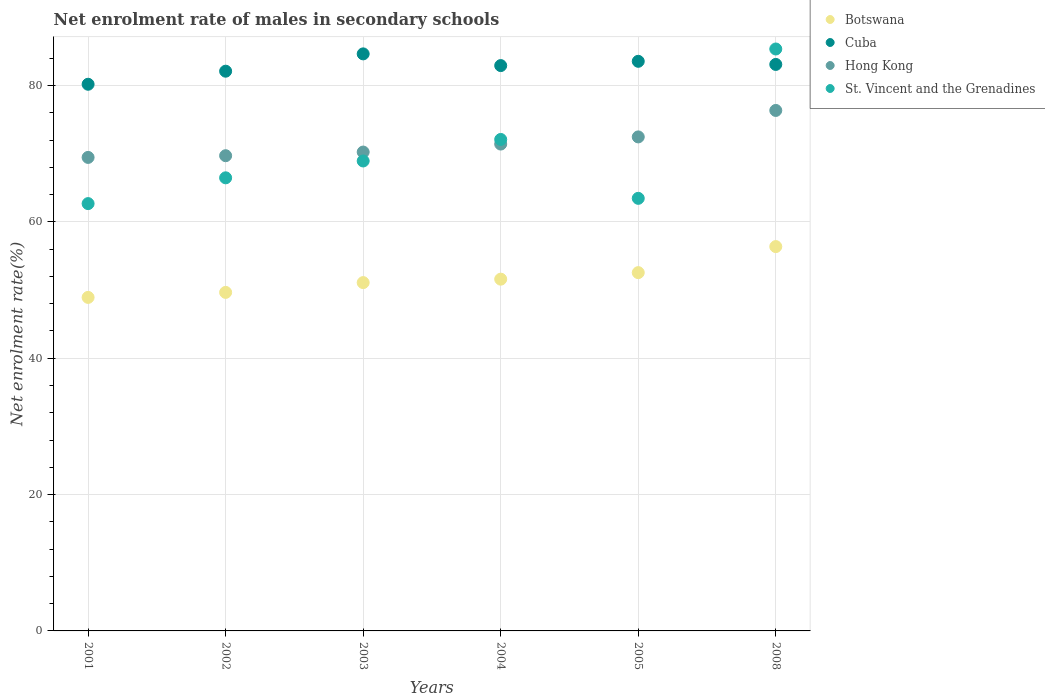How many different coloured dotlines are there?
Your answer should be compact. 4. Is the number of dotlines equal to the number of legend labels?
Make the answer very short. Yes. What is the net enrolment rate of males in secondary schools in Cuba in 2004?
Offer a very short reply. 82.92. Across all years, what is the maximum net enrolment rate of males in secondary schools in Cuba?
Your response must be concise. 84.63. Across all years, what is the minimum net enrolment rate of males in secondary schools in St. Vincent and the Grenadines?
Give a very brief answer. 62.67. In which year was the net enrolment rate of males in secondary schools in Hong Kong maximum?
Offer a terse response. 2008. What is the total net enrolment rate of males in secondary schools in Botswana in the graph?
Your answer should be very brief. 310.17. What is the difference between the net enrolment rate of males in secondary schools in Hong Kong in 2004 and that in 2008?
Make the answer very short. -4.93. What is the difference between the net enrolment rate of males in secondary schools in St. Vincent and the Grenadines in 2002 and the net enrolment rate of males in secondary schools in Hong Kong in 2005?
Provide a short and direct response. -6. What is the average net enrolment rate of males in secondary schools in Botswana per year?
Give a very brief answer. 51.69. In the year 2005, what is the difference between the net enrolment rate of males in secondary schools in Cuba and net enrolment rate of males in secondary schools in Botswana?
Provide a succinct answer. 30.99. What is the ratio of the net enrolment rate of males in secondary schools in Hong Kong in 2002 to that in 2005?
Offer a very short reply. 0.96. What is the difference between the highest and the second highest net enrolment rate of males in secondary schools in St. Vincent and the Grenadines?
Make the answer very short. 13.27. What is the difference between the highest and the lowest net enrolment rate of males in secondary schools in Hong Kong?
Provide a short and direct response. 6.89. In how many years, is the net enrolment rate of males in secondary schools in Cuba greater than the average net enrolment rate of males in secondary schools in Cuba taken over all years?
Your answer should be very brief. 4. Is the sum of the net enrolment rate of males in secondary schools in Botswana in 2003 and 2005 greater than the maximum net enrolment rate of males in secondary schools in Hong Kong across all years?
Make the answer very short. Yes. Is it the case that in every year, the sum of the net enrolment rate of males in secondary schools in Hong Kong and net enrolment rate of males in secondary schools in St. Vincent and the Grenadines  is greater than the sum of net enrolment rate of males in secondary schools in Cuba and net enrolment rate of males in secondary schools in Botswana?
Your answer should be very brief. Yes. Is it the case that in every year, the sum of the net enrolment rate of males in secondary schools in Cuba and net enrolment rate of males in secondary schools in Botswana  is greater than the net enrolment rate of males in secondary schools in Hong Kong?
Give a very brief answer. Yes. Is the net enrolment rate of males in secondary schools in Hong Kong strictly greater than the net enrolment rate of males in secondary schools in Cuba over the years?
Keep it short and to the point. No. How many dotlines are there?
Ensure brevity in your answer.  4. Are the values on the major ticks of Y-axis written in scientific E-notation?
Offer a terse response. No. Does the graph contain any zero values?
Provide a short and direct response. No. Does the graph contain grids?
Your answer should be compact. Yes. Where does the legend appear in the graph?
Provide a succinct answer. Top right. How many legend labels are there?
Your answer should be very brief. 4. How are the legend labels stacked?
Your answer should be compact. Vertical. What is the title of the graph?
Your response must be concise. Net enrolment rate of males in secondary schools. Does "Singapore" appear as one of the legend labels in the graph?
Provide a succinct answer. No. What is the label or title of the Y-axis?
Provide a short and direct response. Net enrolment rate(%). What is the Net enrolment rate(%) of Botswana in 2001?
Keep it short and to the point. 48.92. What is the Net enrolment rate(%) in Cuba in 2001?
Offer a very short reply. 80.18. What is the Net enrolment rate(%) of Hong Kong in 2001?
Your answer should be very brief. 69.45. What is the Net enrolment rate(%) of St. Vincent and the Grenadines in 2001?
Provide a short and direct response. 62.67. What is the Net enrolment rate(%) of Botswana in 2002?
Make the answer very short. 49.65. What is the Net enrolment rate(%) in Cuba in 2002?
Ensure brevity in your answer.  82.09. What is the Net enrolment rate(%) of Hong Kong in 2002?
Offer a terse response. 69.7. What is the Net enrolment rate(%) in St. Vincent and the Grenadines in 2002?
Offer a very short reply. 66.46. What is the Net enrolment rate(%) of Botswana in 2003?
Provide a short and direct response. 51.09. What is the Net enrolment rate(%) in Cuba in 2003?
Ensure brevity in your answer.  84.63. What is the Net enrolment rate(%) of Hong Kong in 2003?
Provide a short and direct response. 70.24. What is the Net enrolment rate(%) in St. Vincent and the Grenadines in 2003?
Ensure brevity in your answer.  68.93. What is the Net enrolment rate(%) of Botswana in 2004?
Ensure brevity in your answer.  51.59. What is the Net enrolment rate(%) in Cuba in 2004?
Your answer should be compact. 82.92. What is the Net enrolment rate(%) of Hong Kong in 2004?
Your answer should be very brief. 71.41. What is the Net enrolment rate(%) of St. Vincent and the Grenadines in 2004?
Your answer should be compact. 72.08. What is the Net enrolment rate(%) in Botswana in 2005?
Make the answer very short. 52.55. What is the Net enrolment rate(%) in Cuba in 2005?
Offer a terse response. 83.54. What is the Net enrolment rate(%) in Hong Kong in 2005?
Your answer should be very brief. 72.46. What is the Net enrolment rate(%) in St. Vincent and the Grenadines in 2005?
Give a very brief answer. 63.45. What is the Net enrolment rate(%) of Botswana in 2008?
Ensure brevity in your answer.  56.37. What is the Net enrolment rate(%) of Cuba in 2008?
Make the answer very short. 83.09. What is the Net enrolment rate(%) in Hong Kong in 2008?
Provide a short and direct response. 76.34. What is the Net enrolment rate(%) of St. Vincent and the Grenadines in 2008?
Ensure brevity in your answer.  85.35. Across all years, what is the maximum Net enrolment rate(%) in Botswana?
Your response must be concise. 56.37. Across all years, what is the maximum Net enrolment rate(%) in Cuba?
Offer a very short reply. 84.63. Across all years, what is the maximum Net enrolment rate(%) of Hong Kong?
Your answer should be very brief. 76.34. Across all years, what is the maximum Net enrolment rate(%) of St. Vincent and the Grenadines?
Make the answer very short. 85.35. Across all years, what is the minimum Net enrolment rate(%) of Botswana?
Provide a short and direct response. 48.92. Across all years, what is the minimum Net enrolment rate(%) in Cuba?
Offer a terse response. 80.18. Across all years, what is the minimum Net enrolment rate(%) of Hong Kong?
Ensure brevity in your answer.  69.45. Across all years, what is the minimum Net enrolment rate(%) of St. Vincent and the Grenadines?
Give a very brief answer. 62.67. What is the total Net enrolment rate(%) in Botswana in the graph?
Provide a short and direct response. 310.17. What is the total Net enrolment rate(%) of Cuba in the graph?
Give a very brief answer. 496.46. What is the total Net enrolment rate(%) in Hong Kong in the graph?
Your answer should be compact. 429.59. What is the total Net enrolment rate(%) of St. Vincent and the Grenadines in the graph?
Make the answer very short. 418.94. What is the difference between the Net enrolment rate(%) in Botswana in 2001 and that in 2002?
Make the answer very short. -0.73. What is the difference between the Net enrolment rate(%) in Cuba in 2001 and that in 2002?
Provide a short and direct response. -1.92. What is the difference between the Net enrolment rate(%) of Hong Kong in 2001 and that in 2002?
Provide a short and direct response. -0.25. What is the difference between the Net enrolment rate(%) in St. Vincent and the Grenadines in 2001 and that in 2002?
Your response must be concise. -3.78. What is the difference between the Net enrolment rate(%) in Botswana in 2001 and that in 2003?
Your response must be concise. -2.17. What is the difference between the Net enrolment rate(%) of Cuba in 2001 and that in 2003?
Your answer should be compact. -4.46. What is the difference between the Net enrolment rate(%) of Hong Kong in 2001 and that in 2003?
Your answer should be compact. -0.79. What is the difference between the Net enrolment rate(%) of St. Vincent and the Grenadines in 2001 and that in 2003?
Provide a succinct answer. -6.25. What is the difference between the Net enrolment rate(%) of Botswana in 2001 and that in 2004?
Give a very brief answer. -2.68. What is the difference between the Net enrolment rate(%) in Cuba in 2001 and that in 2004?
Your answer should be very brief. -2.74. What is the difference between the Net enrolment rate(%) of Hong Kong in 2001 and that in 2004?
Keep it short and to the point. -1.96. What is the difference between the Net enrolment rate(%) in St. Vincent and the Grenadines in 2001 and that in 2004?
Make the answer very short. -9.41. What is the difference between the Net enrolment rate(%) in Botswana in 2001 and that in 2005?
Your answer should be compact. -3.63. What is the difference between the Net enrolment rate(%) of Cuba in 2001 and that in 2005?
Provide a short and direct response. -3.37. What is the difference between the Net enrolment rate(%) of Hong Kong in 2001 and that in 2005?
Ensure brevity in your answer.  -3.01. What is the difference between the Net enrolment rate(%) in St. Vincent and the Grenadines in 2001 and that in 2005?
Provide a short and direct response. -0.77. What is the difference between the Net enrolment rate(%) in Botswana in 2001 and that in 2008?
Provide a succinct answer. -7.45. What is the difference between the Net enrolment rate(%) in Cuba in 2001 and that in 2008?
Ensure brevity in your answer.  -2.91. What is the difference between the Net enrolment rate(%) in Hong Kong in 2001 and that in 2008?
Provide a short and direct response. -6.89. What is the difference between the Net enrolment rate(%) in St. Vincent and the Grenadines in 2001 and that in 2008?
Your answer should be very brief. -22.68. What is the difference between the Net enrolment rate(%) in Botswana in 2002 and that in 2003?
Your answer should be compact. -1.44. What is the difference between the Net enrolment rate(%) of Cuba in 2002 and that in 2003?
Your answer should be very brief. -2.54. What is the difference between the Net enrolment rate(%) in Hong Kong in 2002 and that in 2003?
Keep it short and to the point. -0.54. What is the difference between the Net enrolment rate(%) in St. Vincent and the Grenadines in 2002 and that in 2003?
Make the answer very short. -2.47. What is the difference between the Net enrolment rate(%) of Botswana in 2002 and that in 2004?
Your answer should be very brief. -1.94. What is the difference between the Net enrolment rate(%) of Cuba in 2002 and that in 2004?
Make the answer very short. -0.82. What is the difference between the Net enrolment rate(%) of Hong Kong in 2002 and that in 2004?
Provide a short and direct response. -1.71. What is the difference between the Net enrolment rate(%) in St. Vincent and the Grenadines in 2002 and that in 2004?
Offer a very short reply. -5.63. What is the difference between the Net enrolment rate(%) in Botswana in 2002 and that in 2005?
Your answer should be very brief. -2.9. What is the difference between the Net enrolment rate(%) of Cuba in 2002 and that in 2005?
Offer a terse response. -1.45. What is the difference between the Net enrolment rate(%) of Hong Kong in 2002 and that in 2005?
Your response must be concise. -2.76. What is the difference between the Net enrolment rate(%) of St. Vincent and the Grenadines in 2002 and that in 2005?
Offer a terse response. 3.01. What is the difference between the Net enrolment rate(%) in Botswana in 2002 and that in 2008?
Offer a terse response. -6.72. What is the difference between the Net enrolment rate(%) in Cuba in 2002 and that in 2008?
Offer a very short reply. -0.99. What is the difference between the Net enrolment rate(%) of Hong Kong in 2002 and that in 2008?
Give a very brief answer. -6.64. What is the difference between the Net enrolment rate(%) in St. Vincent and the Grenadines in 2002 and that in 2008?
Give a very brief answer. -18.89. What is the difference between the Net enrolment rate(%) of Botswana in 2003 and that in 2004?
Offer a very short reply. -0.51. What is the difference between the Net enrolment rate(%) in Cuba in 2003 and that in 2004?
Offer a terse response. 1.72. What is the difference between the Net enrolment rate(%) in Hong Kong in 2003 and that in 2004?
Your answer should be very brief. -1.17. What is the difference between the Net enrolment rate(%) of St. Vincent and the Grenadines in 2003 and that in 2004?
Keep it short and to the point. -3.16. What is the difference between the Net enrolment rate(%) of Botswana in 2003 and that in 2005?
Offer a very short reply. -1.46. What is the difference between the Net enrolment rate(%) of Cuba in 2003 and that in 2005?
Ensure brevity in your answer.  1.09. What is the difference between the Net enrolment rate(%) in Hong Kong in 2003 and that in 2005?
Keep it short and to the point. -2.22. What is the difference between the Net enrolment rate(%) in St. Vincent and the Grenadines in 2003 and that in 2005?
Make the answer very short. 5.48. What is the difference between the Net enrolment rate(%) in Botswana in 2003 and that in 2008?
Your answer should be very brief. -5.28. What is the difference between the Net enrolment rate(%) of Cuba in 2003 and that in 2008?
Make the answer very short. 1.55. What is the difference between the Net enrolment rate(%) of Hong Kong in 2003 and that in 2008?
Offer a terse response. -6.1. What is the difference between the Net enrolment rate(%) in St. Vincent and the Grenadines in 2003 and that in 2008?
Keep it short and to the point. -16.42. What is the difference between the Net enrolment rate(%) in Botswana in 2004 and that in 2005?
Provide a succinct answer. -0.96. What is the difference between the Net enrolment rate(%) in Cuba in 2004 and that in 2005?
Your answer should be very brief. -0.63. What is the difference between the Net enrolment rate(%) in Hong Kong in 2004 and that in 2005?
Your answer should be compact. -1.05. What is the difference between the Net enrolment rate(%) of St. Vincent and the Grenadines in 2004 and that in 2005?
Offer a very short reply. 8.64. What is the difference between the Net enrolment rate(%) of Botswana in 2004 and that in 2008?
Your answer should be compact. -4.78. What is the difference between the Net enrolment rate(%) in Cuba in 2004 and that in 2008?
Provide a short and direct response. -0.17. What is the difference between the Net enrolment rate(%) of Hong Kong in 2004 and that in 2008?
Offer a very short reply. -4.93. What is the difference between the Net enrolment rate(%) of St. Vincent and the Grenadines in 2004 and that in 2008?
Provide a short and direct response. -13.27. What is the difference between the Net enrolment rate(%) in Botswana in 2005 and that in 2008?
Offer a very short reply. -3.82. What is the difference between the Net enrolment rate(%) of Cuba in 2005 and that in 2008?
Offer a terse response. 0.46. What is the difference between the Net enrolment rate(%) of Hong Kong in 2005 and that in 2008?
Your response must be concise. -3.88. What is the difference between the Net enrolment rate(%) of St. Vincent and the Grenadines in 2005 and that in 2008?
Offer a terse response. -21.9. What is the difference between the Net enrolment rate(%) of Botswana in 2001 and the Net enrolment rate(%) of Cuba in 2002?
Offer a very short reply. -33.18. What is the difference between the Net enrolment rate(%) of Botswana in 2001 and the Net enrolment rate(%) of Hong Kong in 2002?
Keep it short and to the point. -20.78. What is the difference between the Net enrolment rate(%) of Botswana in 2001 and the Net enrolment rate(%) of St. Vincent and the Grenadines in 2002?
Offer a terse response. -17.54. What is the difference between the Net enrolment rate(%) of Cuba in 2001 and the Net enrolment rate(%) of Hong Kong in 2002?
Your response must be concise. 10.48. What is the difference between the Net enrolment rate(%) of Cuba in 2001 and the Net enrolment rate(%) of St. Vincent and the Grenadines in 2002?
Keep it short and to the point. 13.72. What is the difference between the Net enrolment rate(%) in Hong Kong in 2001 and the Net enrolment rate(%) in St. Vincent and the Grenadines in 2002?
Offer a very short reply. 2.99. What is the difference between the Net enrolment rate(%) in Botswana in 2001 and the Net enrolment rate(%) in Cuba in 2003?
Give a very brief answer. -35.72. What is the difference between the Net enrolment rate(%) of Botswana in 2001 and the Net enrolment rate(%) of Hong Kong in 2003?
Keep it short and to the point. -21.32. What is the difference between the Net enrolment rate(%) of Botswana in 2001 and the Net enrolment rate(%) of St. Vincent and the Grenadines in 2003?
Provide a short and direct response. -20.01. What is the difference between the Net enrolment rate(%) of Cuba in 2001 and the Net enrolment rate(%) of Hong Kong in 2003?
Offer a very short reply. 9.94. What is the difference between the Net enrolment rate(%) in Cuba in 2001 and the Net enrolment rate(%) in St. Vincent and the Grenadines in 2003?
Your response must be concise. 11.25. What is the difference between the Net enrolment rate(%) in Hong Kong in 2001 and the Net enrolment rate(%) in St. Vincent and the Grenadines in 2003?
Provide a succinct answer. 0.52. What is the difference between the Net enrolment rate(%) in Botswana in 2001 and the Net enrolment rate(%) in Cuba in 2004?
Keep it short and to the point. -34. What is the difference between the Net enrolment rate(%) of Botswana in 2001 and the Net enrolment rate(%) of Hong Kong in 2004?
Offer a terse response. -22.49. What is the difference between the Net enrolment rate(%) of Botswana in 2001 and the Net enrolment rate(%) of St. Vincent and the Grenadines in 2004?
Your answer should be very brief. -23.17. What is the difference between the Net enrolment rate(%) in Cuba in 2001 and the Net enrolment rate(%) in Hong Kong in 2004?
Your answer should be very brief. 8.77. What is the difference between the Net enrolment rate(%) in Cuba in 2001 and the Net enrolment rate(%) in St. Vincent and the Grenadines in 2004?
Your answer should be compact. 8.09. What is the difference between the Net enrolment rate(%) in Hong Kong in 2001 and the Net enrolment rate(%) in St. Vincent and the Grenadines in 2004?
Ensure brevity in your answer.  -2.63. What is the difference between the Net enrolment rate(%) in Botswana in 2001 and the Net enrolment rate(%) in Cuba in 2005?
Ensure brevity in your answer.  -34.63. What is the difference between the Net enrolment rate(%) in Botswana in 2001 and the Net enrolment rate(%) in Hong Kong in 2005?
Ensure brevity in your answer.  -23.54. What is the difference between the Net enrolment rate(%) of Botswana in 2001 and the Net enrolment rate(%) of St. Vincent and the Grenadines in 2005?
Keep it short and to the point. -14.53. What is the difference between the Net enrolment rate(%) in Cuba in 2001 and the Net enrolment rate(%) in Hong Kong in 2005?
Offer a very short reply. 7.72. What is the difference between the Net enrolment rate(%) of Cuba in 2001 and the Net enrolment rate(%) of St. Vincent and the Grenadines in 2005?
Ensure brevity in your answer.  16.73. What is the difference between the Net enrolment rate(%) in Hong Kong in 2001 and the Net enrolment rate(%) in St. Vincent and the Grenadines in 2005?
Keep it short and to the point. 6. What is the difference between the Net enrolment rate(%) in Botswana in 2001 and the Net enrolment rate(%) in Cuba in 2008?
Your answer should be very brief. -34.17. What is the difference between the Net enrolment rate(%) of Botswana in 2001 and the Net enrolment rate(%) of Hong Kong in 2008?
Keep it short and to the point. -27.42. What is the difference between the Net enrolment rate(%) of Botswana in 2001 and the Net enrolment rate(%) of St. Vincent and the Grenadines in 2008?
Give a very brief answer. -36.43. What is the difference between the Net enrolment rate(%) in Cuba in 2001 and the Net enrolment rate(%) in Hong Kong in 2008?
Keep it short and to the point. 3.84. What is the difference between the Net enrolment rate(%) of Cuba in 2001 and the Net enrolment rate(%) of St. Vincent and the Grenadines in 2008?
Provide a succinct answer. -5.17. What is the difference between the Net enrolment rate(%) of Hong Kong in 2001 and the Net enrolment rate(%) of St. Vincent and the Grenadines in 2008?
Offer a very short reply. -15.9. What is the difference between the Net enrolment rate(%) in Botswana in 2002 and the Net enrolment rate(%) in Cuba in 2003?
Offer a very short reply. -34.98. What is the difference between the Net enrolment rate(%) of Botswana in 2002 and the Net enrolment rate(%) of Hong Kong in 2003?
Provide a succinct answer. -20.58. What is the difference between the Net enrolment rate(%) of Botswana in 2002 and the Net enrolment rate(%) of St. Vincent and the Grenadines in 2003?
Give a very brief answer. -19.28. What is the difference between the Net enrolment rate(%) of Cuba in 2002 and the Net enrolment rate(%) of Hong Kong in 2003?
Ensure brevity in your answer.  11.86. What is the difference between the Net enrolment rate(%) in Cuba in 2002 and the Net enrolment rate(%) in St. Vincent and the Grenadines in 2003?
Provide a short and direct response. 13.17. What is the difference between the Net enrolment rate(%) of Hong Kong in 2002 and the Net enrolment rate(%) of St. Vincent and the Grenadines in 2003?
Your answer should be compact. 0.77. What is the difference between the Net enrolment rate(%) in Botswana in 2002 and the Net enrolment rate(%) in Cuba in 2004?
Offer a terse response. -33.27. What is the difference between the Net enrolment rate(%) in Botswana in 2002 and the Net enrolment rate(%) in Hong Kong in 2004?
Your answer should be compact. -21.76. What is the difference between the Net enrolment rate(%) of Botswana in 2002 and the Net enrolment rate(%) of St. Vincent and the Grenadines in 2004?
Your response must be concise. -22.43. What is the difference between the Net enrolment rate(%) in Cuba in 2002 and the Net enrolment rate(%) in Hong Kong in 2004?
Provide a short and direct response. 10.69. What is the difference between the Net enrolment rate(%) of Cuba in 2002 and the Net enrolment rate(%) of St. Vincent and the Grenadines in 2004?
Offer a very short reply. 10.01. What is the difference between the Net enrolment rate(%) in Hong Kong in 2002 and the Net enrolment rate(%) in St. Vincent and the Grenadines in 2004?
Your answer should be compact. -2.38. What is the difference between the Net enrolment rate(%) in Botswana in 2002 and the Net enrolment rate(%) in Cuba in 2005?
Give a very brief answer. -33.89. What is the difference between the Net enrolment rate(%) in Botswana in 2002 and the Net enrolment rate(%) in Hong Kong in 2005?
Your answer should be very brief. -22.81. What is the difference between the Net enrolment rate(%) of Botswana in 2002 and the Net enrolment rate(%) of St. Vincent and the Grenadines in 2005?
Your answer should be very brief. -13.8. What is the difference between the Net enrolment rate(%) in Cuba in 2002 and the Net enrolment rate(%) in Hong Kong in 2005?
Your answer should be compact. 9.64. What is the difference between the Net enrolment rate(%) in Cuba in 2002 and the Net enrolment rate(%) in St. Vincent and the Grenadines in 2005?
Provide a succinct answer. 18.65. What is the difference between the Net enrolment rate(%) of Hong Kong in 2002 and the Net enrolment rate(%) of St. Vincent and the Grenadines in 2005?
Your answer should be compact. 6.25. What is the difference between the Net enrolment rate(%) of Botswana in 2002 and the Net enrolment rate(%) of Cuba in 2008?
Keep it short and to the point. -33.44. What is the difference between the Net enrolment rate(%) of Botswana in 2002 and the Net enrolment rate(%) of Hong Kong in 2008?
Your answer should be compact. -26.69. What is the difference between the Net enrolment rate(%) in Botswana in 2002 and the Net enrolment rate(%) in St. Vincent and the Grenadines in 2008?
Give a very brief answer. -35.7. What is the difference between the Net enrolment rate(%) of Cuba in 2002 and the Net enrolment rate(%) of Hong Kong in 2008?
Make the answer very short. 5.76. What is the difference between the Net enrolment rate(%) in Cuba in 2002 and the Net enrolment rate(%) in St. Vincent and the Grenadines in 2008?
Keep it short and to the point. -3.26. What is the difference between the Net enrolment rate(%) of Hong Kong in 2002 and the Net enrolment rate(%) of St. Vincent and the Grenadines in 2008?
Make the answer very short. -15.65. What is the difference between the Net enrolment rate(%) in Botswana in 2003 and the Net enrolment rate(%) in Cuba in 2004?
Ensure brevity in your answer.  -31.83. What is the difference between the Net enrolment rate(%) of Botswana in 2003 and the Net enrolment rate(%) of Hong Kong in 2004?
Make the answer very short. -20.32. What is the difference between the Net enrolment rate(%) of Botswana in 2003 and the Net enrolment rate(%) of St. Vincent and the Grenadines in 2004?
Offer a terse response. -21. What is the difference between the Net enrolment rate(%) in Cuba in 2003 and the Net enrolment rate(%) in Hong Kong in 2004?
Provide a short and direct response. 13.23. What is the difference between the Net enrolment rate(%) of Cuba in 2003 and the Net enrolment rate(%) of St. Vincent and the Grenadines in 2004?
Give a very brief answer. 12.55. What is the difference between the Net enrolment rate(%) in Hong Kong in 2003 and the Net enrolment rate(%) in St. Vincent and the Grenadines in 2004?
Provide a succinct answer. -1.85. What is the difference between the Net enrolment rate(%) of Botswana in 2003 and the Net enrolment rate(%) of Cuba in 2005?
Provide a succinct answer. -32.46. What is the difference between the Net enrolment rate(%) in Botswana in 2003 and the Net enrolment rate(%) in Hong Kong in 2005?
Your answer should be compact. -21.37. What is the difference between the Net enrolment rate(%) of Botswana in 2003 and the Net enrolment rate(%) of St. Vincent and the Grenadines in 2005?
Provide a succinct answer. -12.36. What is the difference between the Net enrolment rate(%) of Cuba in 2003 and the Net enrolment rate(%) of Hong Kong in 2005?
Provide a short and direct response. 12.18. What is the difference between the Net enrolment rate(%) in Cuba in 2003 and the Net enrolment rate(%) in St. Vincent and the Grenadines in 2005?
Your response must be concise. 21.19. What is the difference between the Net enrolment rate(%) in Hong Kong in 2003 and the Net enrolment rate(%) in St. Vincent and the Grenadines in 2005?
Offer a very short reply. 6.79. What is the difference between the Net enrolment rate(%) in Botswana in 2003 and the Net enrolment rate(%) in Cuba in 2008?
Give a very brief answer. -32. What is the difference between the Net enrolment rate(%) of Botswana in 2003 and the Net enrolment rate(%) of Hong Kong in 2008?
Give a very brief answer. -25.25. What is the difference between the Net enrolment rate(%) of Botswana in 2003 and the Net enrolment rate(%) of St. Vincent and the Grenadines in 2008?
Provide a short and direct response. -34.26. What is the difference between the Net enrolment rate(%) of Cuba in 2003 and the Net enrolment rate(%) of Hong Kong in 2008?
Provide a short and direct response. 8.3. What is the difference between the Net enrolment rate(%) in Cuba in 2003 and the Net enrolment rate(%) in St. Vincent and the Grenadines in 2008?
Provide a short and direct response. -0.72. What is the difference between the Net enrolment rate(%) of Hong Kong in 2003 and the Net enrolment rate(%) of St. Vincent and the Grenadines in 2008?
Offer a very short reply. -15.12. What is the difference between the Net enrolment rate(%) of Botswana in 2004 and the Net enrolment rate(%) of Cuba in 2005?
Provide a succinct answer. -31.95. What is the difference between the Net enrolment rate(%) of Botswana in 2004 and the Net enrolment rate(%) of Hong Kong in 2005?
Your response must be concise. -20.86. What is the difference between the Net enrolment rate(%) in Botswana in 2004 and the Net enrolment rate(%) in St. Vincent and the Grenadines in 2005?
Your answer should be compact. -11.85. What is the difference between the Net enrolment rate(%) of Cuba in 2004 and the Net enrolment rate(%) of Hong Kong in 2005?
Your response must be concise. 10.46. What is the difference between the Net enrolment rate(%) of Cuba in 2004 and the Net enrolment rate(%) of St. Vincent and the Grenadines in 2005?
Offer a terse response. 19.47. What is the difference between the Net enrolment rate(%) in Hong Kong in 2004 and the Net enrolment rate(%) in St. Vincent and the Grenadines in 2005?
Offer a very short reply. 7.96. What is the difference between the Net enrolment rate(%) in Botswana in 2004 and the Net enrolment rate(%) in Cuba in 2008?
Ensure brevity in your answer.  -31.49. What is the difference between the Net enrolment rate(%) in Botswana in 2004 and the Net enrolment rate(%) in Hong Kong in 2008?
Provide a succinct answer. -24.74. What is the difference between the Net enrolment rate(%) in Botswana in 2004 and the Net enrolment rate(%) in St. Vincent and the Grenadines in 2008?
Offer a terse response. -33.76. What is the difference between the Net enrolment rate(%) of Cuba in 2004 and the Net enrolment rate(%) of Hong Kong in 2008?
Make the answer very short. 6.58. What is the difference between the Net enrolment rate(%) of Cuba in 2004 and the Net enrolment rate(%) of St. Vincent and the Grenadines in 2008?
Your response must be concise. -2.43. What is the difference between the Net enrolment rate(%) in Hong Kong in 2004 and the Net enrolment rate(%) in St. Vincent and the Grenadines in 2008?
Offer a terse response. -13.94. What is the difference between the Net enrolment rate(%) of Botswana in 2005 and the Net enrolment rate(%) of Cuba in 2008?
Ensure brevity in your answer.  -30.54. What is the difference between the Net enrolment rate(%) in Botswana in 2005 and the Net enrolment rate(%) in Hong Kong in 2008?
Provide a short and direct response. -23.79. What is the difference between the Net enrolment rate(%) in Botswana in 2005 and the Net enrolment rate(%) in St. Vincent and the Grenadines in 2008?
Provide a succinct answer. -32.8. What is the difference between the Net enrolment rate(%) in Cuba in 2005 and the Net enrolment rate(%) in Hong Kong in 2008?
Make the answer very short. 7.21. What is the difference between the Net enrolment rate(%) in Cuba in 2005 and the Net enrolment rate(%) in St. Vincent and the Grenadines in 2008?
Ensure brevity in your answer.  -1.81. What is the difference between the Net enrolment rate(%) of Hong Kong in 2005 and the Net enrolment rate(%) of St. Vincent and the Grenadines in 2008?
Your answer should be compact. -12.89. What is the average Net enrolment rate(%) in Botswana per year?
Ensure brevity in your answer.  51.7. What is the average Net enrolment rate(%) in Cuba per year?
Give a very brief answer. 82.74. What is the average Net enrolment rate(%) of Hong Kong per year?
Offer a terse response. 71.6. What is the average Net enrolment rate(%) of St. Vincent and the Grenadines per year?
Ensure brevity in your answer.  69.82. In the year 2001, what is the difference between the Net enrolment rate(%) in Botswana and Net enrolment rate(%) in Cuba?
Make the answer very short. -31.26. In the year 2001, what is the difference between the Net enrolment rate(%) in Botswana and Net enrolment rate(%) in Hong Kong?
Keep it short and to the point. -20.53. In the year 2001, what is the difference between the Net enrolment rate(%) in Botswana and Net enrolment rate(%) in St. Vincent and the Grenadines?
Your answer should be very brief. -13.76. In the year 2001, what is the difference between the Net enrolment rate(%) of Cuba and Net enrolment rate(%) of Hong Kong?
Keep it short and to the point. 10.73. In the year 2001, what is the difference between the Net enrolment rate(%) in Cuba and Net enrolment rate(%) in St. Vincent and the Grenadines?
Give a very brief answer. 17.5. In the year 2001, what is the difference between the Net enrolment rate(%) of Hong Kong and Net enrolment rate(%) of St. Vincent and the Grenadines?
Offer a terse response. 6.78. In the year 2002, what is the difference between the Net enrolment rate(%) of Botswana and Net enrolment rate(%) of Cuba?
Make the answer very short. -32.44. In the year 2002, what is the difference between the Net enrolment rate(%) of Botswana and Net enrolment rate(%) of Hong Kong?
Offer a very short reply. -20.05. In the year 2002, what is the difference between the Net enrolment rate(%) in Botswana and Net enrolment rate(%) in St. Vincent and the Grenadines?
Offer a very short reply. -16.8. In the year 2002, what is the difference between the Net enrolment rate(%) in Cuba and Net enrolment rate(%) in Hong Kong?
Your answer should be compact. 12.39. In the year 2002, what is the difference between the Net enrolment rate(%) of Cuba and Net enrolment rate(%) of St. Vincent and the Grenadines?
Offer a terse response. 15.64. In the year 2002, what is the difference between the Net enrolment rate(%) of Hong Kong and Net enrolment rate(%) of St. Vincent and the Grenadines?
Ensure brevity in your answer.  3.24. In the year 2003, what is the difference between the Net enrolment rate(%) in Botswana and Net enrolment rate(%) in Cuba?
Your answer should be compact. -33.55. In the year 2003, what is the difference between the Net enrolment rate(%) in Botswana and Net enrolment rate(%) in Hong Kong?
Make the answer very short. -19.15. In the year 2003, what is the difference between the Net enrolment rate(%) in Botswana and Net enrolment rate(%) in St. Vincent and the Grenadines?
Keep it short and to the point. -17.84. In the year 2003, what is the difference between the Net enrolment rate(%) in Cuba and Net enrolment rate(%) in Hong Kong?
Provide a succinct answer. 14.4. In the year 2003, what is the difference between the Net enrolment rate(%) of Cuba and Net enrolment rate(%) of St. Vincent and the Grenadines?
Provide a succinct answer. 15.71. In the year 2003, what is the difference between the Net enrolment rate(%) of Hong Kong and Net enrolment rate(%) of St. Vincent and the Grenadines?
Ensure brevity in your answer.  1.31. In the year 2004, what is the difference between the Net enrolment rate(%) in Botswana and Net enrolment rate(%) in Cuba?
Your response must be concise. -31.32. In the year 2004, what is the difference between the Net enrolment rate(%) of Botswana and Net enrolment rate(%) of Hong Kong?
Make the answer very short. -19.81. In the year 2004, what is the difference between the Net enrolment rate(%) in Botswana and Net enrolment rate(%) in St. Vincent and the Grenadines?
Make the answer very short. -20.49. In the year 2004, what is the difference between the Net enrolment rate(%) of Cuba and Net enrolment rate(%) of Hong Kong?
Provide a succinct answer. 11.51. In the year 2004, what is the difference between the Net enrolment rate(%) of Cuba and Net enrolment rate(%) of St. Vincent and the Grenadines?
Keep it short and to the point. 10.83. In the year 2004, what is the difference between the Net enrolment rate(%) in Hong Kong and Net enrolment rate(%) in St. Vincent and the Grenadines?
Provide a short and direct response. -0.68. In the year 2005, what is the difference between the Net enrolment rate(%) in Botswana and Net enrolment rate(%) in Cuba?
Your answer should be very brief. -30.99. In the year 2005, what is the difference between the Net enrolment rate(%) of Botswana and Net enrolment rate(%) of Hong Kong?
Provide a succinct answer. -19.91. In the year 2005, what is the difference between the Net enrolment rate(%) of Botswana and Net enrolment rate(%) of St. Vincent and the Grenadines?
Offer a terse response. -10.9. In the year 2005, what is the difference between the Net enrolment rate(%) of Cuba and Net enrolment rate(%) of Hong Kong?
Provide a short and direct response. 11.09. In the year 2005, what is the difference between the Net enrolment rate(%) in Cuba and Net enrolment rate(%) in St. Vincent and the Grenadines?
Offer a very short reply. 20.1. In the year 2005, what is the difference between the Net enrolment rate(%) in Hong Kong and Net enrolment rate(%) in St. Vincent and the Grenadines?
Provide a succinct answer. 9.01. In the year 2008, what is the difference between the Net enrolment rate(%) of Botswana and Net enrolment rate(%) of Cuba?
Make the answer very short. -26.72. In the year 2008, what is the difference between the Net enrolment rate(%) in Botswana and Net enrolment rate(%) in Hong Kong?
Keep it short and to the point. -19.97. In the year 2008, what is the difference between the Net enrolment rate(%) of Botswana and Net enrolment rate(%) of St. Vincent and the Grenadines?
Offer a very short reply. -28.98. In the year 2008, what is the difference between the Net enrolment rate(%) of Cuba and Net enrolment rate(%) of Hong Kong?
Give a very brief answer. 6.75. In the year 2008, what is the difference between the Net enrolment rate(%) in Cuba and Net enrolment rate(%) in St. Vincent and the Grenadines?
Your answer should be very brief. -2.26. In the year 2008, what is the difference between the Net enrolment rate(%) in Hong Kong and Net enrolment rate(%) in St. Vincent and the Grenadines?
Your answer should be very brief. -9.01. What is the ratio of the Net enrolment rate(%) of Botswana in 2001 to that in 2002?
Your response must be concise. 0.99. What is the ratio of the Net enrolment rate(%) of Cuba in 2001 to that in 2002?
Offer a very short reply. 0.98. What is the ratio of the Net enrolment rate(%) in St. Vincent and the Grenadines in 2001 to that in 2002?
Make the answer very short. 0.94. What is the ratio of the Net enrolment rate(%) of Botswana in 2001 to that in 2003?
Give a very brief answer. 0.96. What is the ratio of the Net enrolment rate(%) in Cuba in 2001 to that in 2003?
Provide a short and direct response. 0.95. What is the ratio of the Net enrolment rate(%) in St. Vincent and the Grenadines in 2001 to that in 2003?
Keep it short and to the point. 0.91. What is the ratio of the Net enrolment rate(%) of Botswana in 2001 to that in 2004?
Keep it short and to the point. 0.95. What is the ratio of the Net enrolment rate(%) in Cuba in 2001 to that in 2004?
Offer a terse response. 0.97. What is the ratio of the Net enrolment rate(%) in Hong Kong in 2001 to that in 2004?
Make the answer very short. 0.97. What is the ratio of the Net enrolment rate(%) of St. Vincent and the Grenadines in 2001 to that in 2004?
Provide a succinct answer. 0.87. What is the ratio of the Net enrolment rate(%) of Botswana in 2001 to that in 2005?
Offer a very short reply. 0.93. What is the ratio of the Net enrolment rate(%) in Cuba in 2001 to that in 2005?
Keep it short and to the point. 0.96. What is the ratio of the Net enrolment rate(%) of Hong Kong in 2001 to that in 2005?
Keep it short and to the point. 0.96. What is the ratio of the Net enrolment rate(%) of Botswana in 2001 to that in 2008?
Provide a short and direct response. 0.87. What is the ratio of the Net enrolment rate(%) in Hong Kong in 2001 to that in 2008?
Offer a terse response. 0.91. What is the ratio of the Net enrolment rate(%) in St. Vincent and the Grenadines in 2001 to that in 2008?
Offer a very short reply. 0.73. What is the ratio of the Net enrolment rate(%) of Botswana in 2002 to that in 2003?
Make the answer very short. 0.97. What is the ratio of the Net enrolment rate(%) of Cuba in 2002 to that in 2003?
Keep it short and to the point. 0.97. What is the ratio of the Net enrolment rate(%) in Hong Kong in 2002 to that in 2003?
Your response must be concise. 0.99. What is the ratio of the Net enrolment rate(%) in St. Vincent and the Grenadines in 2002 to that in 2003?
Offer a very short reply. 0.96. What is the ratio of the Net enrolment rate(%) in Botswana in 2002 to that in 2004?
Give a very brief answer. 0.96. What is the ratio of the Net enrolment rate(%) of Hong Kong in 2002 to that in 2004?
Your response must be concise. 0.98. What is the ratio of the Net enrolment rate(%) of St. Vincent and the Grenadines in 2002 to that in 2004?
Your answer should be compact. 0.92. What is the ratio of the Net enrolment rate(%) of Botswana in 2002 to that in 2005?
Keep it short and to the point. 0.94. What is the ratio of the Net enrolment rate(%) of Cuba in 2002 to that in 2005?
Offer a terse response. 0.98. What is the ratio of the Net enrolment rate(%) in Hong Kong in 2002 to that in 2005?
Your answer should be very brief. 0.96. What is the ratio of the Net enrolment rate(%) in St. Vincent and the Grenadines in 2002 to that in 2005?
Your answer should be compact. 1.05. What is the ratio of the Net enrolment rate(%) in Botswana in 2002 to that in 2008?
Your response must be concise. 0.88. What is the ratio of the Net enrolment rate(%) of St. Vincent and the Grenadines in 2002 to that in 2008?
Keep it short and to the point. 0.78. What is the ratio of the Net enrolment rate(%) of Botswana in 2003 to that in 2004?
Offer a terse response. 0.99. What is the ratio of the Net enrolment rate(%) of Cuba in 2003 to that in 2004?
Your response must be concise. 1.02. What is the ratio of the Net enrolment rate(%) of Hong Kong in 2003 to that in 2004?
Give a very brief answer. 0.98. What is the ratio of the Net enrolment rate(%) in St. Vincent and the Grenadines in 2003 to that in 2004?
Provide a succinct answer. 0.96. What is the ratio of the Net enrolment rate(%) in Botswana in 2003 to that in 2005?
Your answer should be very brief. 0.97. What is the ratio of the Net enrolment rate(%) of Cuba in 2003 to that in 2005?
Offer a very short reply. 1.01. What is the ratio of the Net enrolment rate(%) of Hong Kong in 2003 to that in 2005?
Keep it short and to the point. 0.97. What is the ratio of the Net enrolment rate(%) of St. Vincent and the Grenadines in 2003 to that in 2005?
Provide a succinct answer. 1.09. What is the ratio of the Net enrolment rate(%) of Botswana in 2003 to that in 2008?
Offer a terse response. 0.91. What is the ratio of the Net enrolment rate(%) of Cuba in 2003 to that in 2008?
Give a very brief answer. 1.02. What is the ratio of the Net enrolment rate(%) of Hong Kong in 2003 to that in 2008?
Your answer should be very brief. 0.92. What is the ratio of the Net enrolment rate(%) of St. Vincent and the Grenadines in 2003 to that in 2008?
Offer a terse response. 0.81. What is the ratio of the Net enrolment rate(%) of Botswana in 2004 to that in 2005?
Provide a succinct answer. 0.98. What is the ratio of the Net enrolment rate(%) of Cuba in 2004 to that in 2005?
Offer a terse response. 0.99. What is the ratio of the Net enrolment rate(%) in Hong Kong in 2004 to that in 2005?
Provide a succinct answer. 0.99. What is the ratio of the Net enrolment rate(%) in St. Vincent and the Grenadines in 2004 to that in 2005?
Your response must be concise. 1.14. What is the ratio of the Net enrolment rate(%) of Botswana in 2004 to that in 2008?
Your response must be concise. 0.92. What is the ratio of the Net enrolment rate(%) of Cuba in 2004 to that in 2008?
Your answer should be compact. 1. What is the ratio of the Net enrolment rate(%) in Hong Kong in 2004 to that in 2008?
Give a very brief answer. 0.94. What is the ratio of the Net enrolment rate(%) of St. Vincent and the Grenadines in 2004 to that in 2008?
Your answer should be very brief. 0.84. What is the ratio of the Net enrolment rate(%) in Botswana in 2005 to that in 2008?
Your answer should be compact. 0.93. What is the ratio of the Net enrolment rate(%) in Cuba in 2005 to that in 2008?
Your response must be concise. 1.01. What is the ratio of the Net enrolment rate(%) in Hong Kong in 2005 to that in 2008?
Your answer should be compact. 0.95. What is the ratio of the Net enrolment rate(%) of St. Vincent and the Grenadines in 2005 to that in 2008?
Your response must be concise. 0.74. What is the difference between the highest and the second highest Net enrolment rate(%) in Botswana?
Offer a terse response. 3.82. What is the difference between the highest and the second highest Net enrolment rate(%) in Cuba?
Your response must be concise. 1.09. What is the difference between the highest and the second highest Net enrolment rate(%) of Hong Kong?
Offer a very short reply. 3.88. What is the difference between the highest and the second highest Net enrolment rate(%) in St. Vincent and the Grenadines?
Offer a very short reply. 13.27. What is the difference between the highest and the lowest Net enrolment rate(%) in Botswana?
Your answer should be compact. 7.45. What is the difference between the highest and the lowest Net enrolment rate(%) of Cuba?
Provide a succinct answer. 4.46. What is the difference between the highest and the lowest Net enrolment rate(%) of Hong Kong?
Offer a very short reply. 6.89. What is the difference between the highest and the lowest Net enrolment rate(%) of St. Vincent and the Grenadines?
Provide a succinct answer. 22.68. 